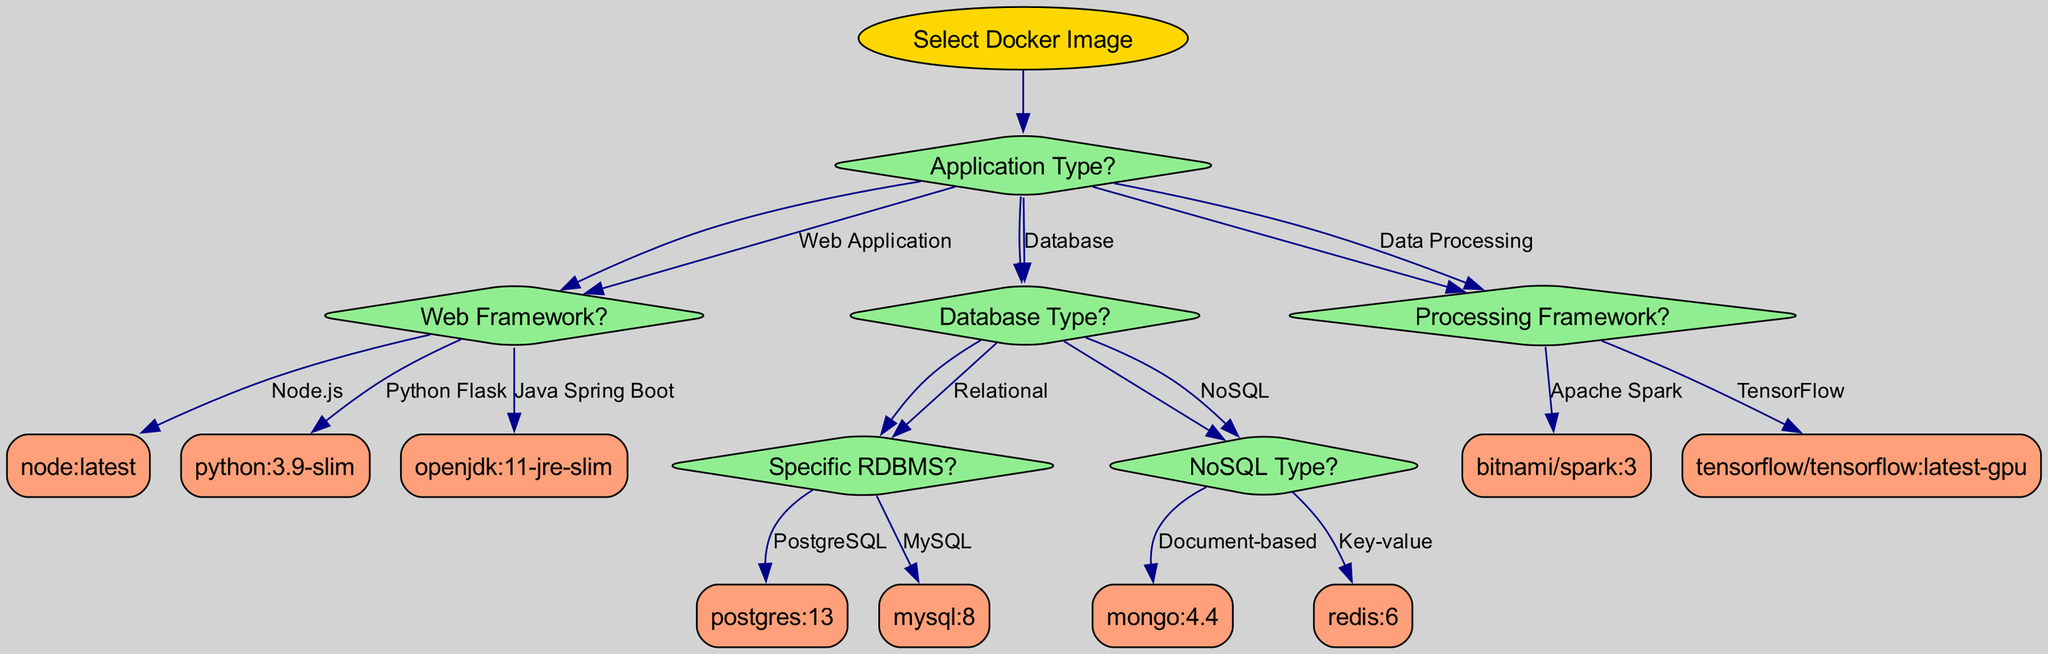What is the root of the decision tree? The root of the decision tree is indicated at the top and is labeled "Select Docker Image".
Answer: Select Docker Image How many application types are listed under the first question? The first question presents three options for application types: Web Application, Database, and Data Processing, which totals three options.
Answer: 3 What Docker image corresponds to a Python Flask web application? Following the decision tree, if the application type is a Web Application and the framework is Python Flask, the resulting Docker image is specified as "python:3.9-slim".
Answer: python:3.9-slim How many distinct NoSQL types are available in the decision tree? The decision tree provides two NoSQL types under the question "NoSQL Type": Document-based and Key-value, leading to a total of two distinct options.
Answer: 2 If a user selects "Relational" under Database Type, what is the next question they will encounter? From the "Database Type?" question, choosing "Relational" leads directly to the next question "Specific RDBMS?".
Answer: Specific RDBMS? What is the outcome if the chosen database type is "PostgreSQL"? Selecting "PostgreSQL" under the "Specific RDBMS?" question will produce the Docker image "postgres:13" as the result.
Answer: postgres:13 Which Docker image is recommended for an application using Apache Spark? According to the decision tree, if the chosen processing framework is Apache Spark, the associated Docker image is "bitnami/spark:3".
Answer: bitnami/spark:3 What is the relationship between the "Web Application" and "Web Framework?" nodes? The "Web Application" option leads to a subsequent question "Web Framework?", establishing a direct flow in the decision-making process of selecting the appropriate Docker image based on application requirements.
Answer: Direct flow If the initial choice is "Data Processing" and the framework chosen is "TensorFlow", what image is selected? The decision path leads from the "Data Processing" choice to the "Processing Framework?" question, where selecting "TensorFlow" results in the Docker image "tensorflow/tensorflow:latest-gpu".
Answer: tensorflow/tensorflow:latest-gpu 